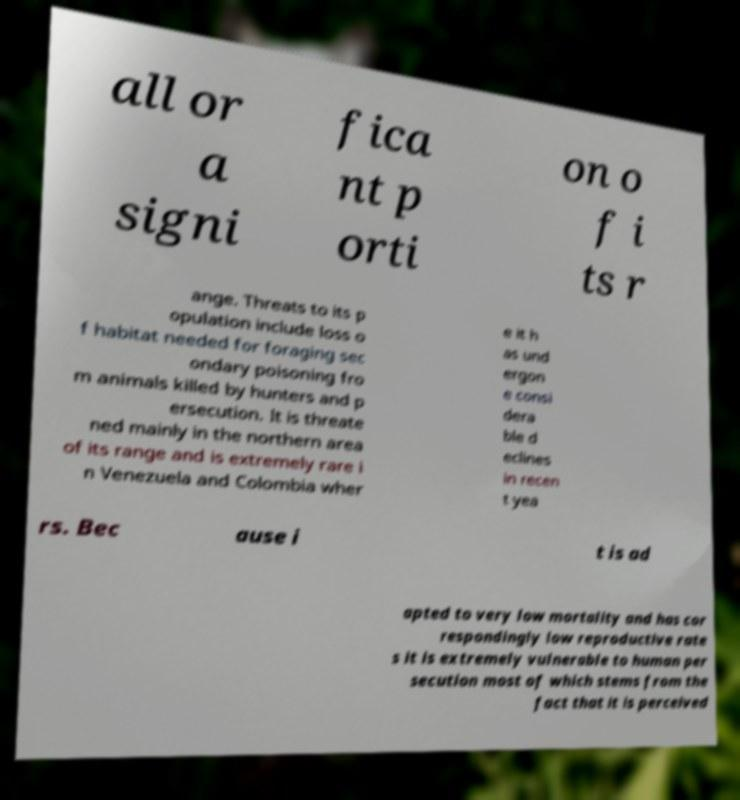Can you read and provide the text displayed in the image?This photo seems to have some interesting text. Can you extract and type it out for me? all or a signi fica nt p orti on o f i ts r ange. Threats to its p opulation include loss o f habitat needed for foraging sec ondary poisoning fro m animals killed by hunters and p ersecution. It is threate ned mainly in the northern area of its range and is extremely rare i n Venezuela and Colombia wher e it h as und ergon e consi dera ble d eclines in recen t yea rs. Bec ause i t is ad apted to very low mortality and has cor respondingly low reproductive rate s it is extremely vulnerable to human per secution most of which stems from the fact that it is perceived 